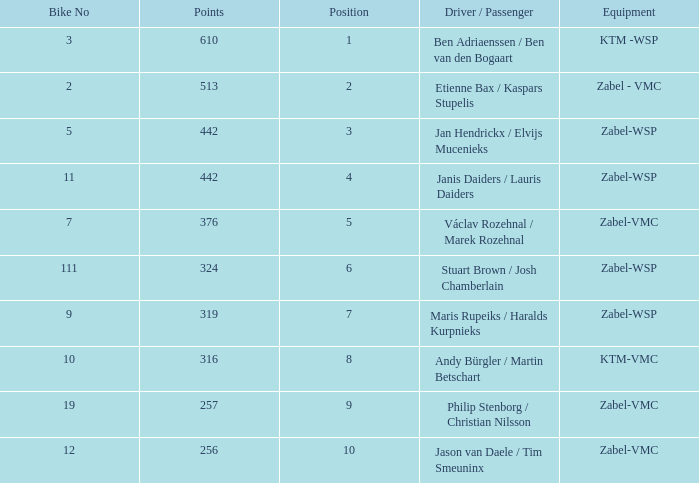What is the Equipment that has a Point bigger than 256, and a Position of 3? Zabel-WSP. 